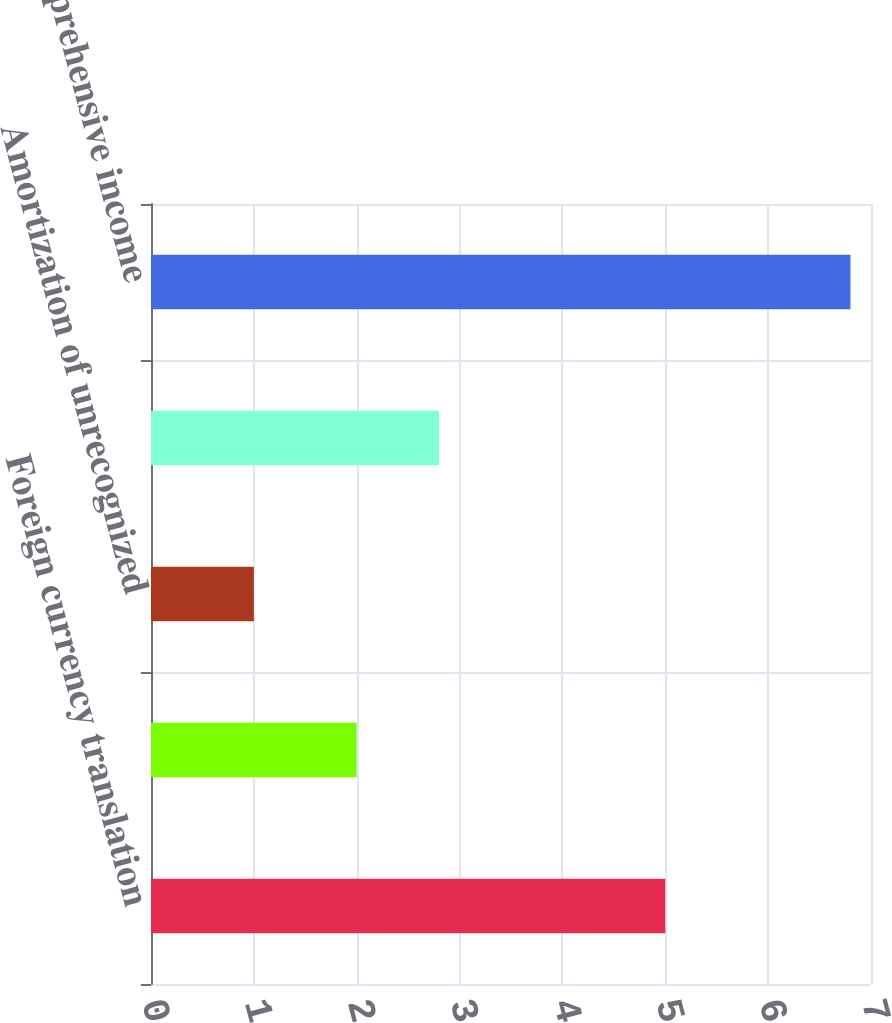<chart> <loc_0><loc_0><loc_500><loc_500><bar_chart><fcel>Foreign currency translation<fcel>Net actuarial (loss) gain<fcel>Amortization of unrecognized<fcel>(Loss) gain on forward<fcel>Other comprehensive income<nl><fcel>5<fcel>2<fcel>1<fcel>2.8<fcel>6.8<nl></chart> 